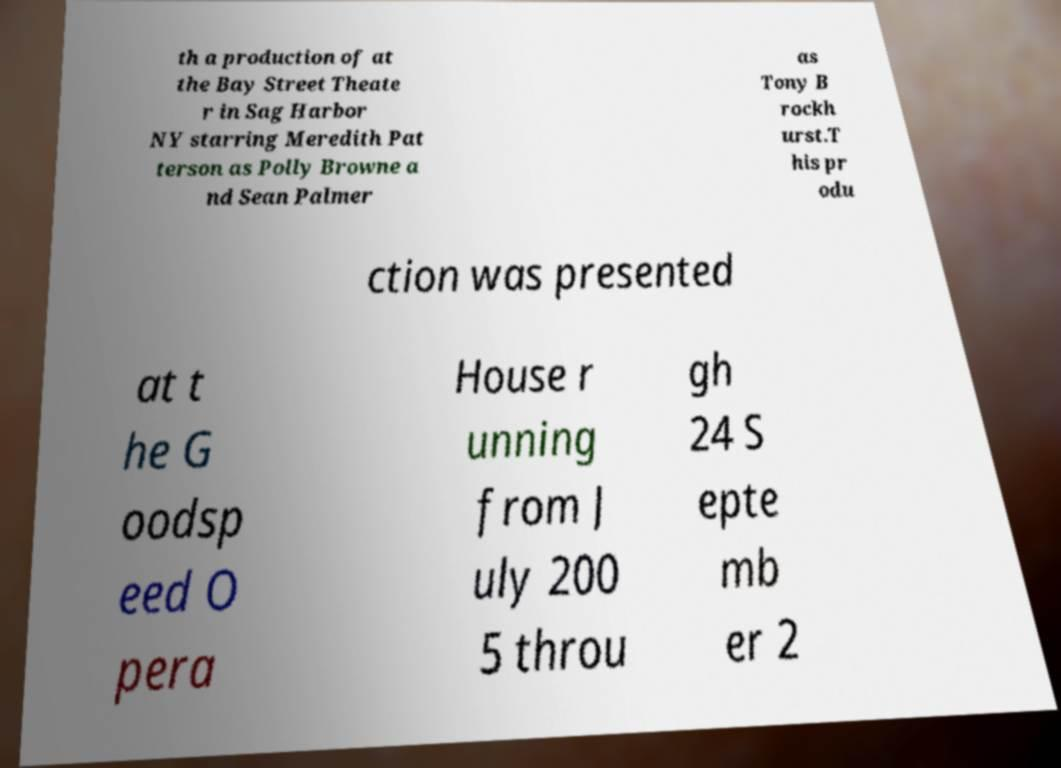Please identify and transcribe the text found in this image. th a production of at the Bay Street Theate r in Sag Harbor NY starring Meredith Pat terson as Polly Browne a nd Sean Palmer as Tony B rockh urst.T his pr odu ction was presented at t he G oodsp eed O pera House r unning from J uly 200 5 throu gh 24 S epte mb er 2 